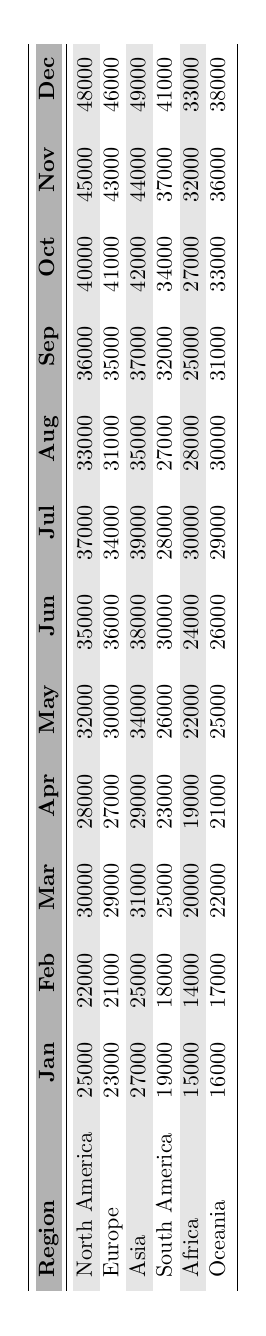What region had the highest sales in December? By looking at the December column in the table, we can see that North America has the highest value at 48,000.
Answer: North America What was the total sales for South America from January to March? We add South America's sales for January (19,000), February (18,000), and March (25,000). The total is 19,000 + 18,000 + 25,000 = 62,000.
Answer: 62000 Did Africa's sales increase every month throughout 2023? By inspecting the sales figures month by month for Africa, we see that there are decreases in sales from February to March and from March to April, so the sales did not increase every month.
Answer: No Which region had the highest sales in June, and what was that value? Comparing the sales figures for June, North America has 35,000, while the others have lower values. Therefore, North America has the highest sales in June.
Answer: 35000 What is the average sales for Asia from April to June? We sum the sales for Asia in April (29,000), May (34,000), and June (38,000), which gives us a total of 29,000 + 34,000 + 38,000 = 101,000. Dividing by 3 gives an average of 33,667.
Answer: 33667 Which region had the lowest sales in February? By checking the sales figures for February across all regions, Africa has the lowest sales at 14,000.
Answer: Africa What was the difference in sales between October and December for Europe? The sales in December for Europe is 46,000 and in October, it is 41,000. Therefore, the difference is 46,000 - 41,000 = 5,000.
Answer: 5000 Is it true that Oceania had the same sales figures for August and June? Looking at the sales in June (26,000) and August (30,000) for Oceania, we see they are not the same, meaning it is false.
Answer: No Which region consistently had sales over 30,000 from June to December? Upon reviewing the sales data, we find that both North America and Asia consistently have sales over 30,000 from June to December.
Answer: North America and Asia What is the total sales for all regions in November? Adding up the sales for all regions in November: North America (45,000) + Europe (43,000) + Asia (44,000) + South America (37,000) + Africa (32,000) + Oceania (36,000) equals 237,000.
Answer: 237000 